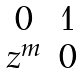<formula> <loc_0><loc_0><loc_500><loc_500>\begin{matrix} 0 & 1 \\ z ^ { m } & 0 \end{matrix}</formula> 